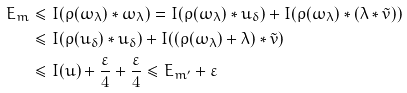<formula> <loc_0><loc_0><loc_500><loc_500>E _ { m } & \leq I ( \rho ( \omega _ { \lambda } ) * \omega _ { \lambda } ) = I ( \rho ( \omega _ { \lambda } ) * u _ { \delta } ) + I ( \rho ( \omega _ { \lambda } ) * ( \lambda * \tilde { v } ) ) \\ & \leq I ( \rho ( u _ { \delta } ) * u _ { \delta } ) + I ( ( \rho ( \omega _ { \lambda } ) + \lambda ) * \tilde { v } ) \\ & \leq I ( u ) + \frac { \varepsilon } { 4 } + \frac { \varepsilon } { 4 } \leq E _ { m ^ { \prime } } + \varepsilon</formula> 